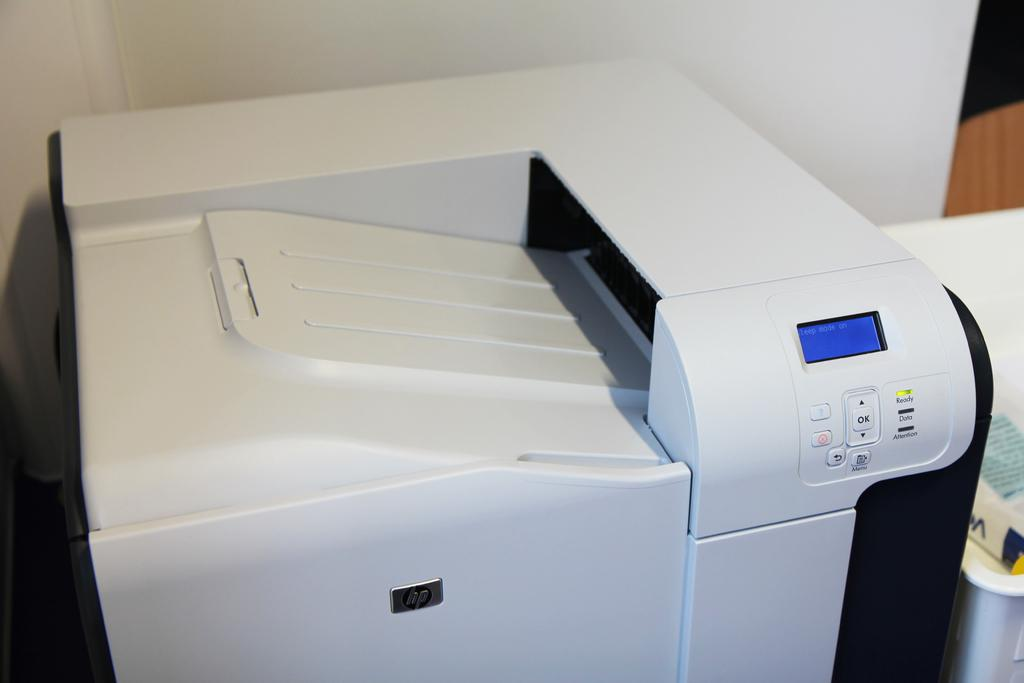Provide a one-sentence caption for the provided image. A white HP copier is in sleep mode. 